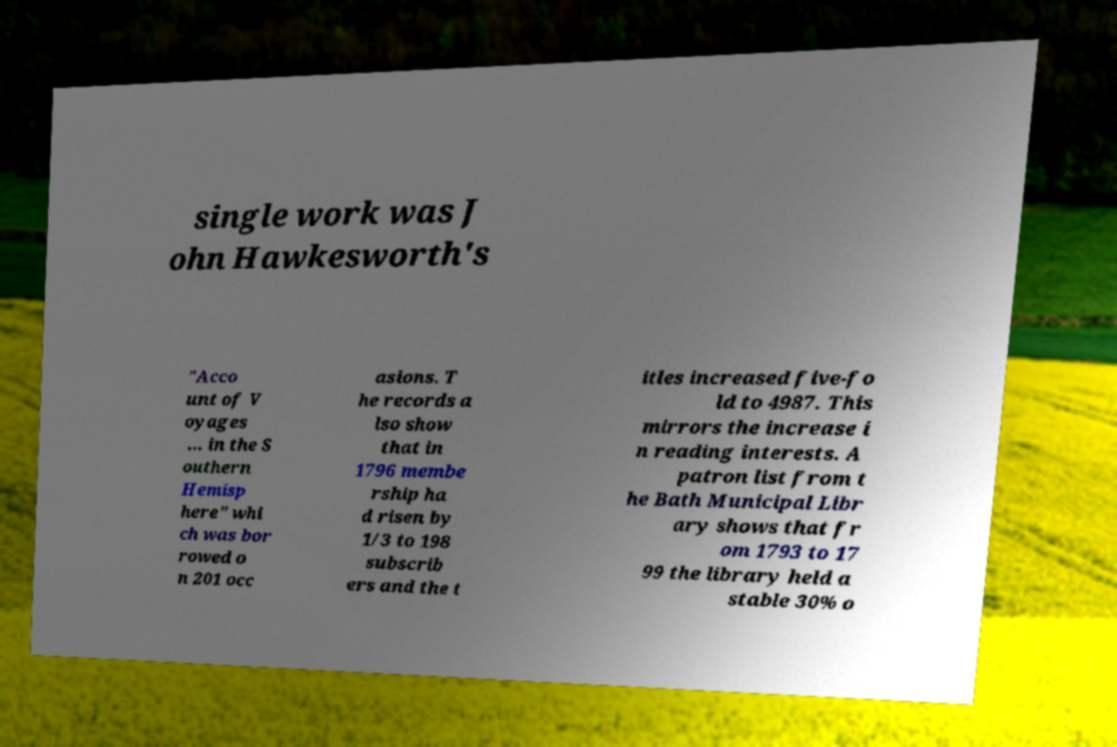Could you extract and type out the text from this image? single work was J ohn Hawkesworth's "Acco unt of V oyages ... in the S outhern Hemisp here" whi ch was bor rowed o n 201 occ asions. T he records a lso show that in 1796 membe rship ha d risen by 1/3 to 198 subscrib ers and the t itles increased five-fo ld to 4987. This mirrors the increase i n reading interests. A patron list from t he Bath Municipal Libr ary shows that fr om 1793 to 17 99 the library held a stable 30% o 